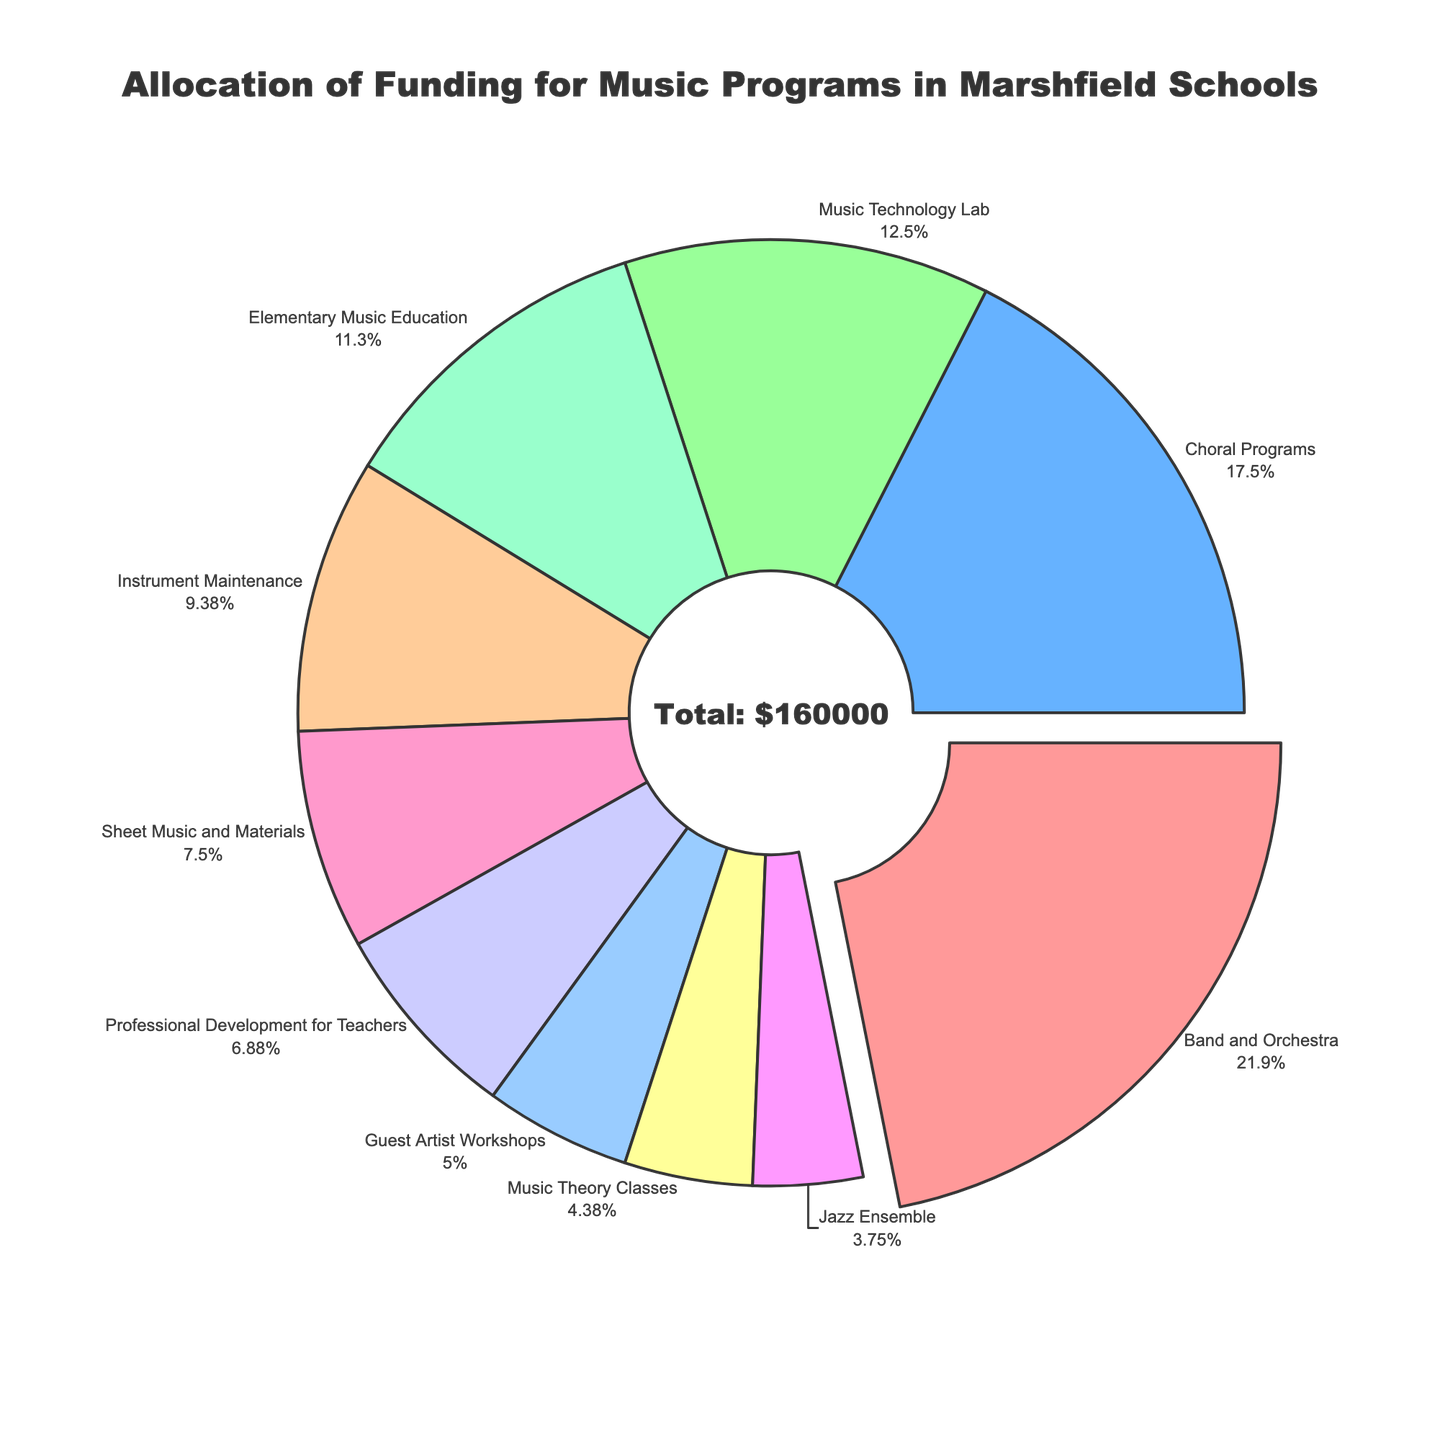What percentage of the total funding is allocated to Band and Orchestra? The Band and Orchestra segment is the largest and appears to be pulled out in the pie chart. The figure indicates its percentage, which is the largest slice.
Answer: 22.3% How much more funding does Choral Programs receive compared to Jazz Ensemble? Choral Programs receive $28,000, while Jazz Ensemble receives $6,000. The difference is $28,000 - $6,000.
Answer: $22,000 What is the combined funding allocation for Music Technology Lab and Elementary Music Education? The funding for Music Technology Lab is $20,000, and for Elementary Music Education, it is $18,000. Adding these gives $20,000 + $18,000.
Answer: $38,000 Which program receives the least amount of funding and what percentage does it represent? The pie chart shows the smallest segment is for Music Theory Classes, which is funded $7,000. The figure indicates the percentage for each segment.
Answer: 4.5% Are Guest Artist Workshops funded more than Elementary Music Education? Comparing the allocated amounts, Guest Artist Workshops receive $8,000, while Elementary Music Education receives $18,000.
Answer: No If the funding for Professional Development for Teachers increased by $4,000, what would be the new total funding for music programs? Currently, total funding is $180,000. Increasing the funding for Professional Development from $11,000 to $15,000 changes the total to $180,000 + $4,000.
Answer: $184,000 What is the visual indication that Band and Orchestra receive the highest funding? The Band and Orchestra slice is visually pulled out from the pie chart, and it represents the largest slice.
Answer: Pulled out and largest slice By approximately how much does the funding for Sheet Music and Materials exceed that for Jazz Ensemble? Sheet Music and Materials receive $12,000 while Jazz Ensemble receives $6,000. The difference is $12,000 - $6,000.
Answer: $6,000 